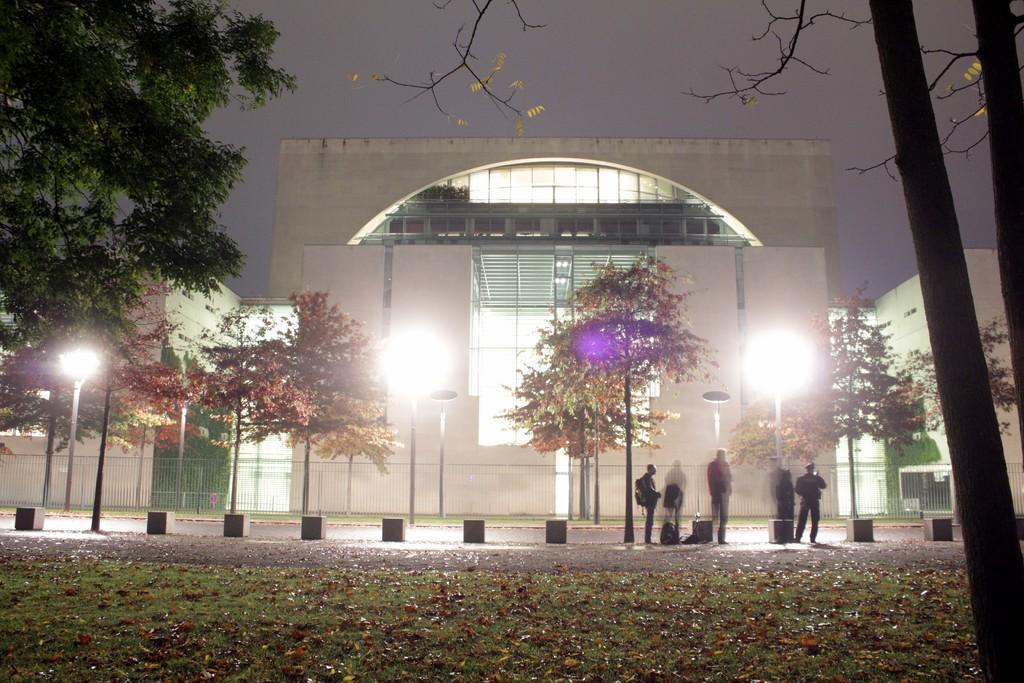Could you give a brief overview of what you see in this image? In the foreground of this image, there is grassland dried leaves and trees. In the background, there are few persons standing on the road, few trees, road diving objects and the poles. In the background, there are buildings, fencing and the sky. 